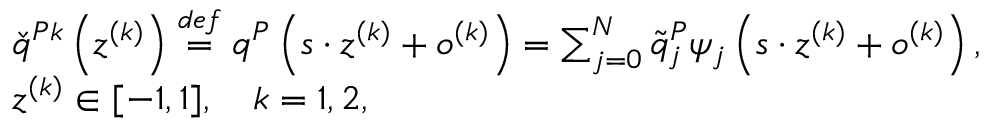Convert formula to latex. <formula><loc_0><loc_0><loc_500><loc_500>\begin{array} { r l } & { \check { q } ^ { P k } \left ( z ^ { ( k ) } \right ) \overset { d e f } { = } q ^ { P } \left ( s \cdot z ^ { ( k ) } + o ^ { ( k ) } \right ) = \sum _ { j = 0 } ^ { N } \tilde { q } _ { j } ^ { P } \psi _ { j } \left ( s \cdot z ^ { ( k ) } + o ^ { ( k ) } \right ) , } \\ & { z ^ { ( k ) } \in [ - 1 , 1 ] , \quad k = 1 , 2 , } \end{array}</formula> 